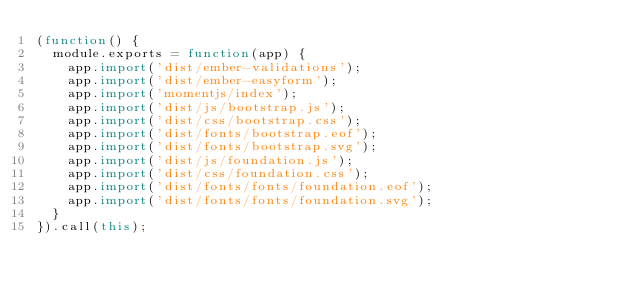<code> <loc_0><loc_0><loc_500><loc_500><_JavaScript_>(function() {
  module.exports = function(app) {
    app.import('dist/ember-validations');
    app.import('dist/ember-easyform');
    app.import('momentjs/index');
    app.import('dist/js/bootstrap.js');
    app.import('dist/css/bootstrap.css');
    app.import('dist/fonts/bootstrap.eof');
    app.import('dist/fonts/bootstrap.svg');
    app.import('dist/js/foundation.js');
    app.import('dist/css/foundation.css');
    app.import('dist/fonts/fonts/foundation.eof');
    app.import('dist/fonts/fonts/foundation.svg');
  }
}).call(this);</code> 